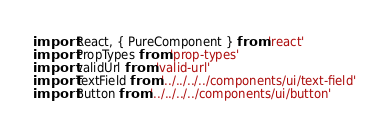<code> <loc_0><loc_0><loc_500><loc_500><_JavaScript_>import React, { PureComponent } from 'react'
import PropTypes from 'prop-types'
import validUrl from 'valid-url'
import TextField from '../../../../components/ui/text-field'
import Button from '../../../../components/ui/button'
</code> 